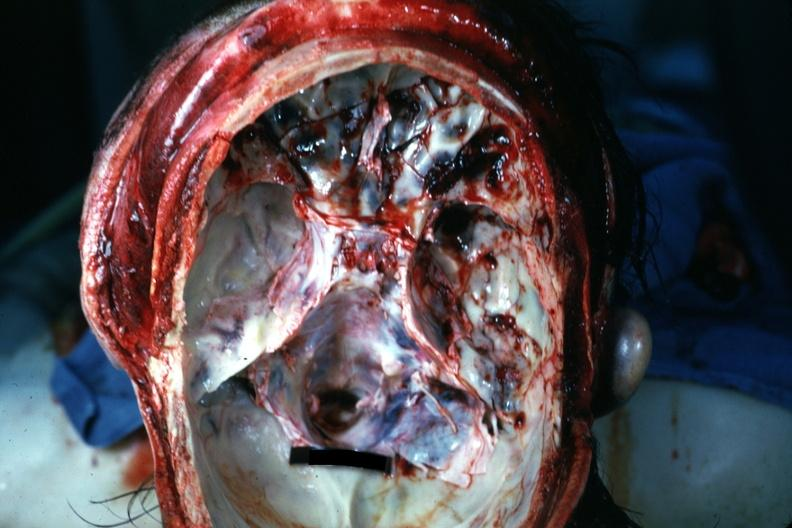what is present?
Answer the question using a single word or phrase. Basilar skull fracture 